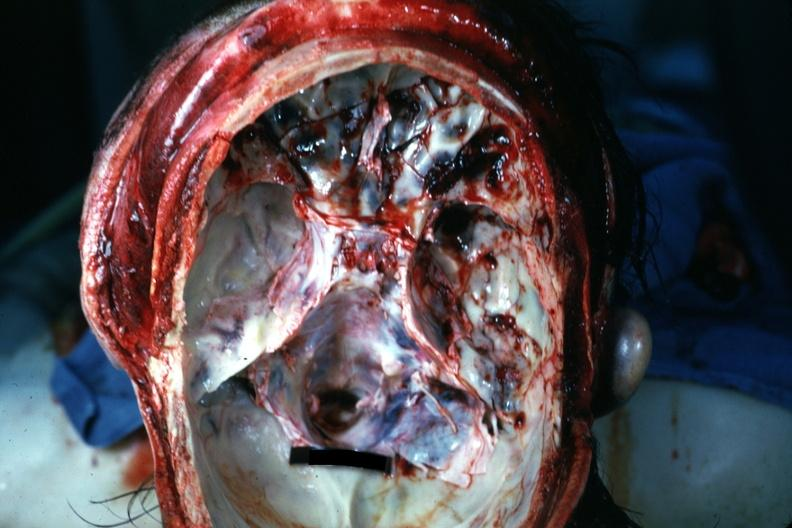what is present?
Answer the question using a single word or phrase. Basilar skull fracture 